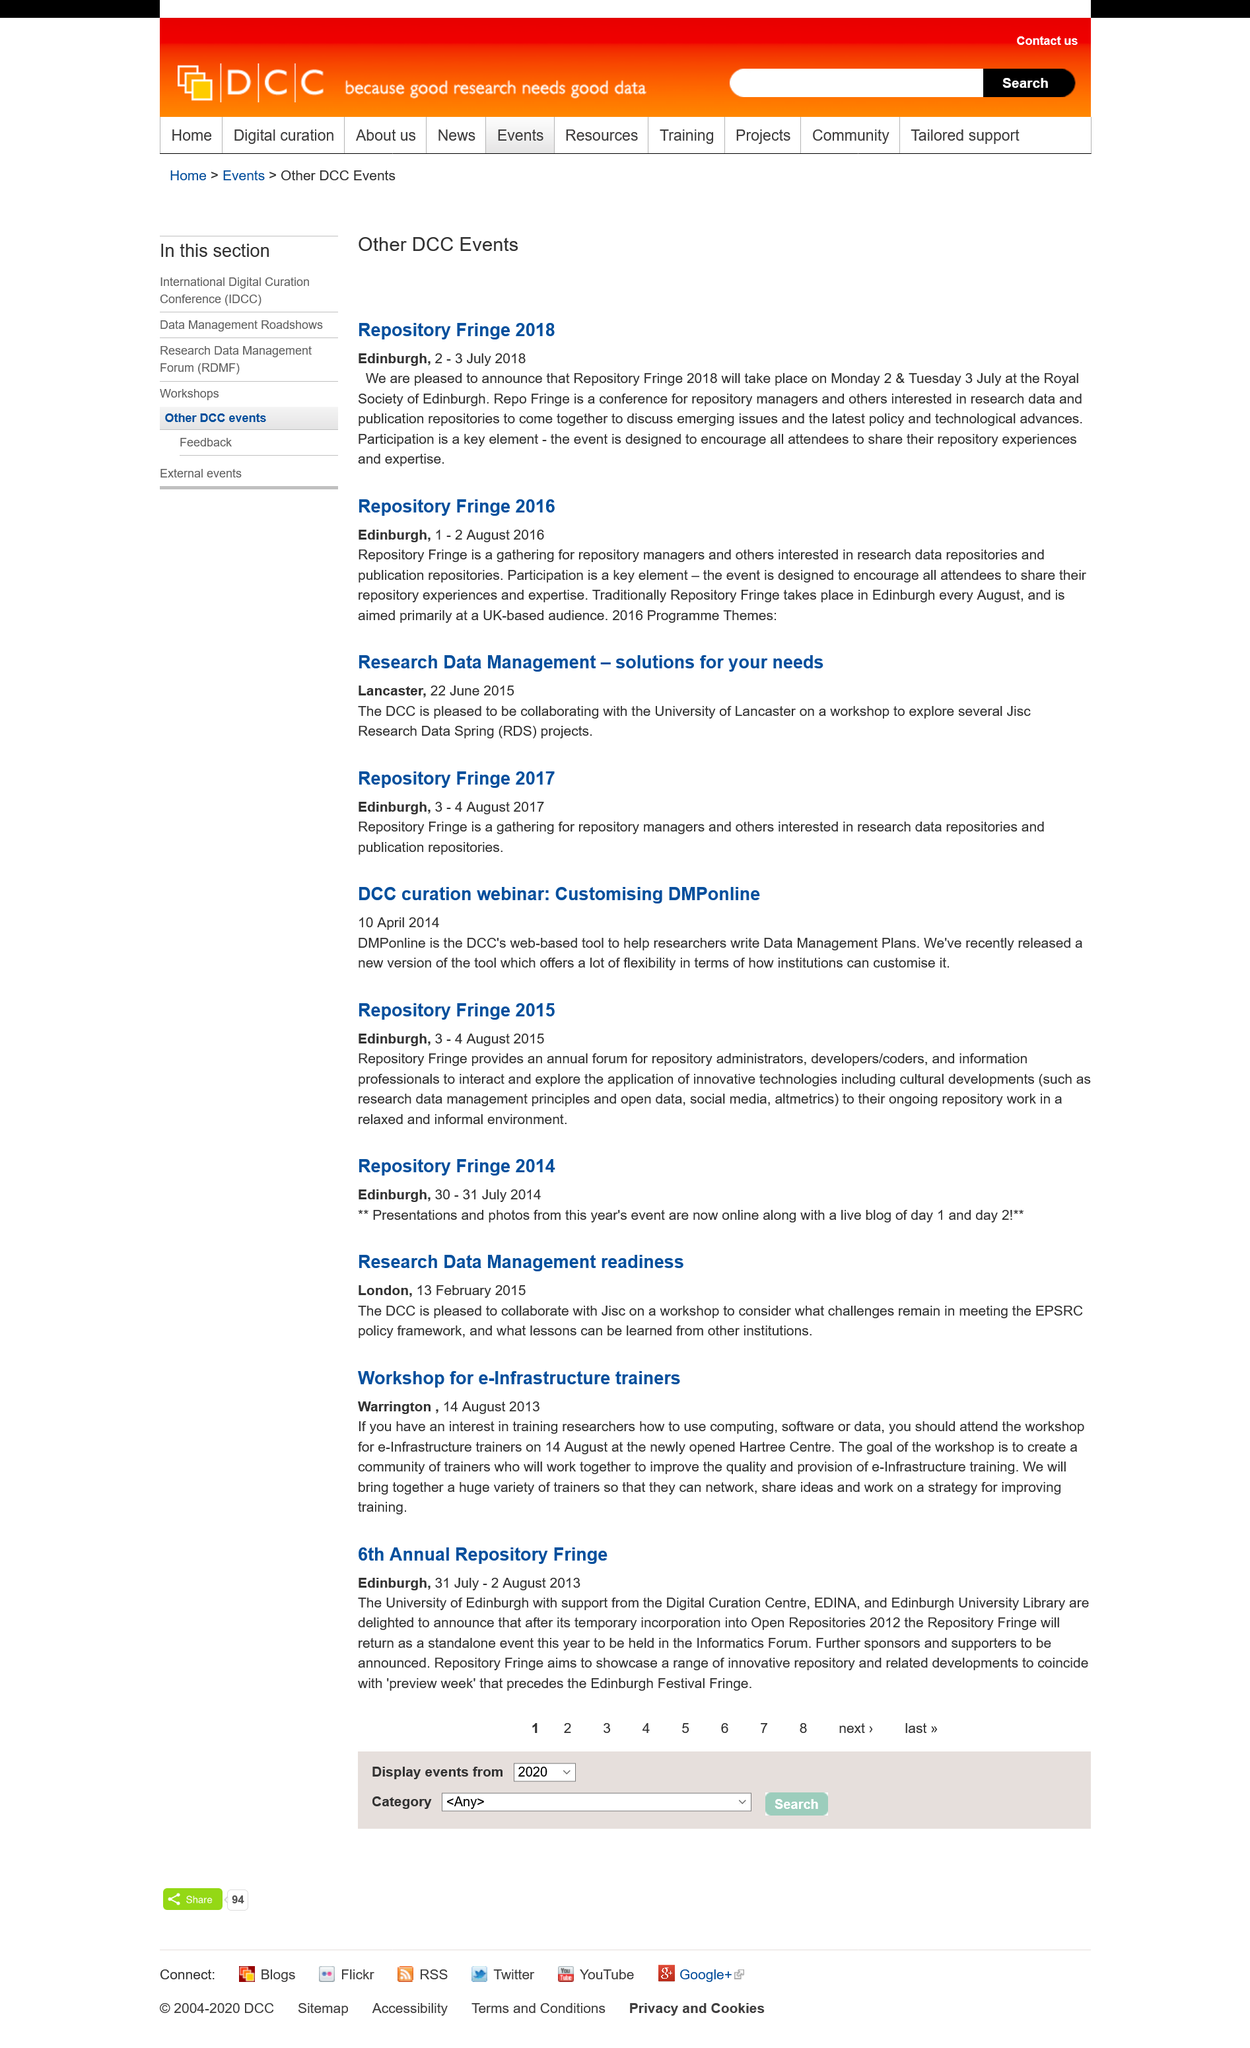Specify some key components in this picture. The Repository Fringe provides a platform for Repository administrators, developers, coders, and information professionals to exchange ideas and explore the application of innovative technologies and cultural developments. The Research Data Management readiness workshop is being held in London. The Repository Fringe forum is an annual event that takes place. The topic of the DCC curation webinar was customizing DMPonline. Yes, Repository Fringe 2018 and 2016 were both held in Edinburgh. 